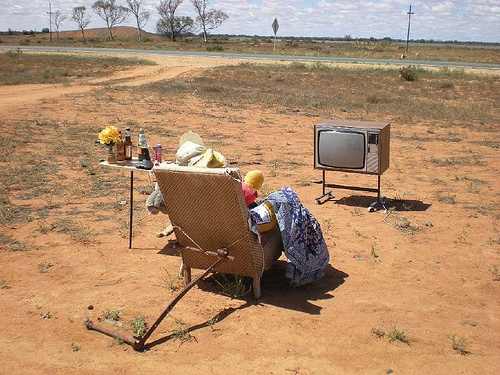Describe the objects in this image and their specific colors. I can see chair in darkgray, maroon, gray, and black tones, people in darkgray, gray, black, and white tones, tv in darkgray, gray, maroon, and black tones, dining table in darkgray, tan, black, and gray tones, and people in darkgray, olive, brown, tan, and khaki tones in this image. 